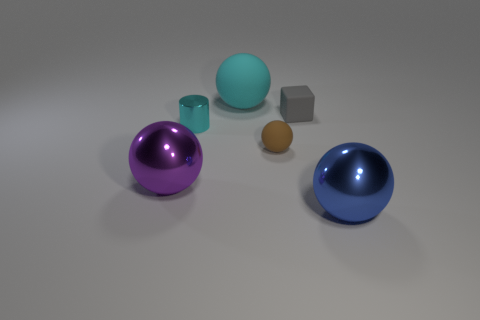How many rubber things are big cyan spheres or small brown objects?
Your answer should be very brief. 2. What size is the sphere that is in front of the brown rubber object and to the left of the blue metal thing?
Ensure brevity in your answer.  Large. Are there any shiny things that are on the left side of the big metallic sphere in front of the large purple sphere?
Provide a succinct answer. Yes. There is a cylinder; what number of matte spheres are behind it?
Keep it short and to the point. 1. The tiny object that is the same shape as the large cyan thing is what color?
Provide a succinct answer. Brown. Is the material of the large cyan ball to the left of the blue ball the same as the small brown ball that is in front of the rubber block?
Make the answer very short. Yes. There is a shiny cylinder; is its color the same as the matte sphere behind the cyan metal object?
Give a very brief answer. Yes. What is the shape of the thing that is left of the small cube and in front of the brown object?
Provide a succinct answer. Sphere. What number of small green cubes are there?
Your response must be concise. 0. What shape is the large rubber object that is the same color as the small cylinder?
Offer a very short reply. Sphere. 